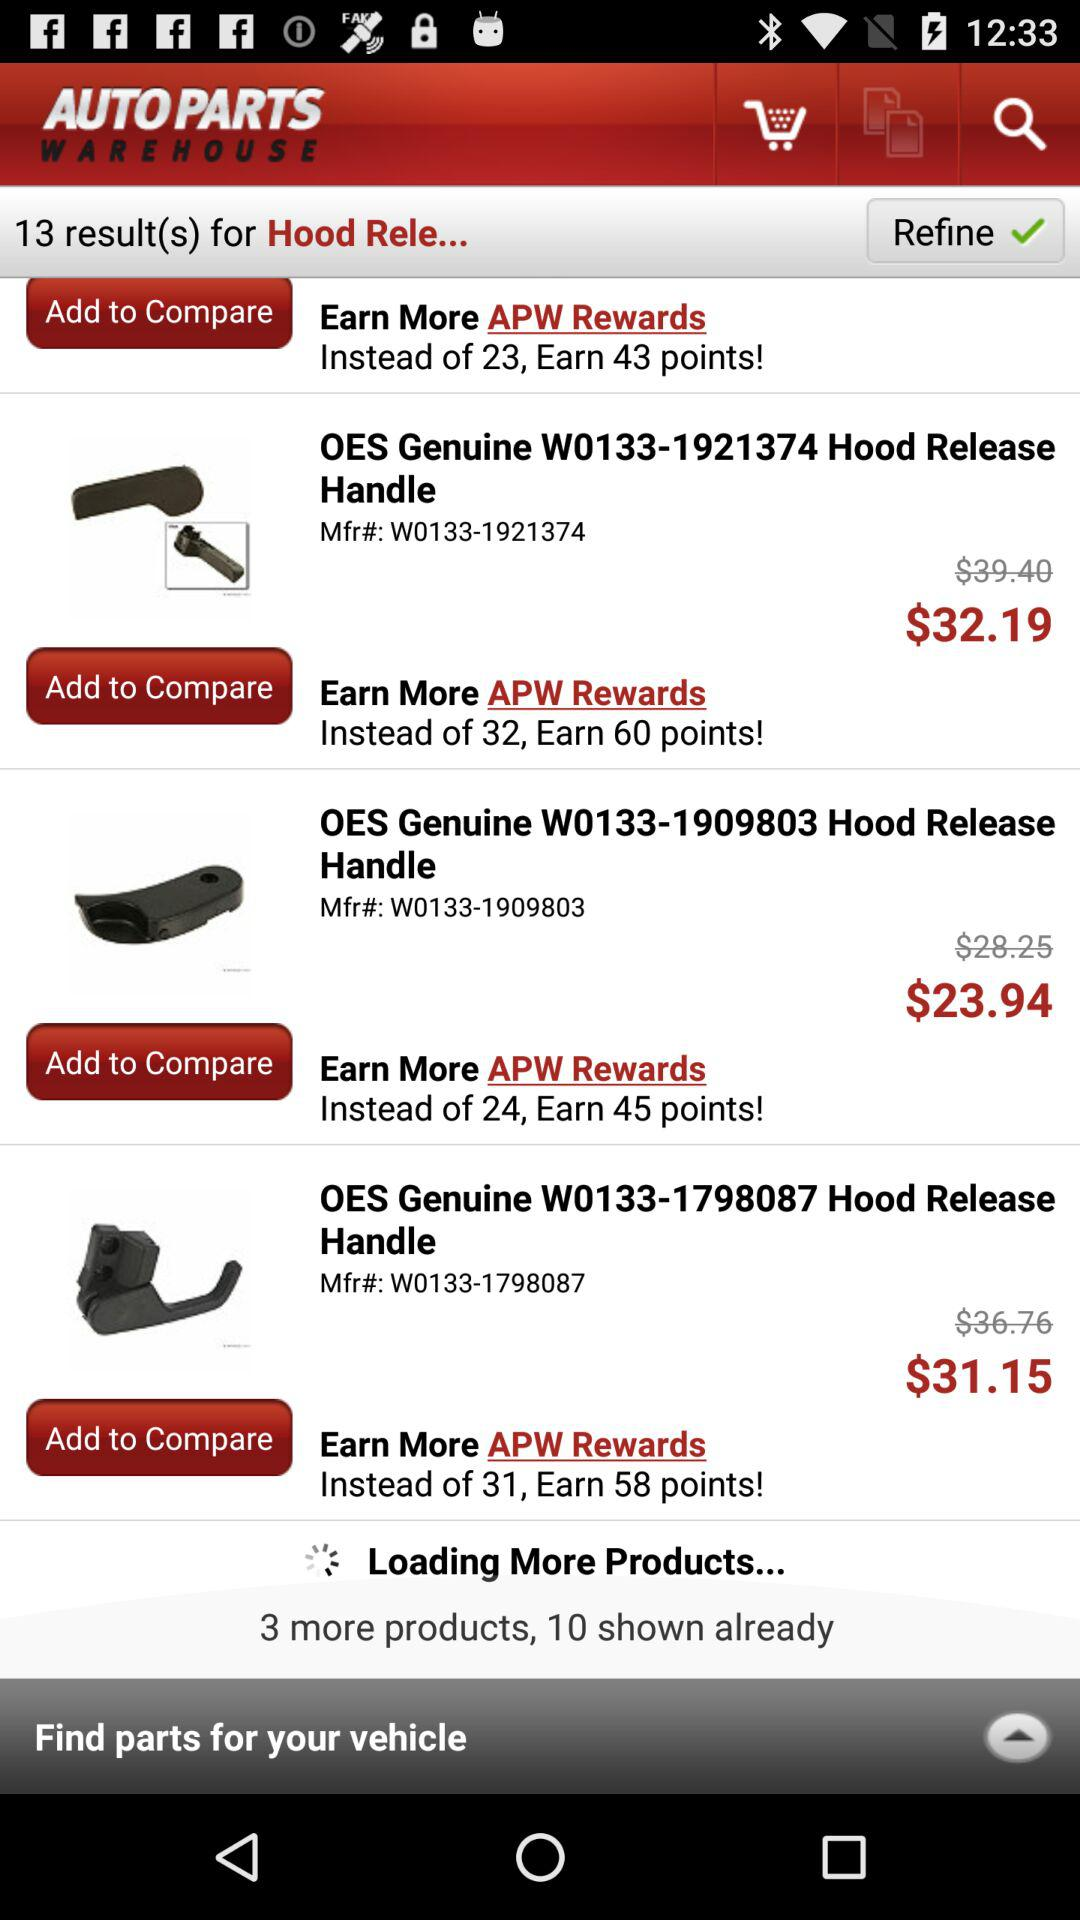How many results were found for "Hood Release"? There were 13 results found for "Hood Release". 